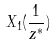<formula> <loc_0><loc_0><loc_500><loc_500>X _ { 1 } ( \frac { 1 } { z ^ { * } } )</formula> 